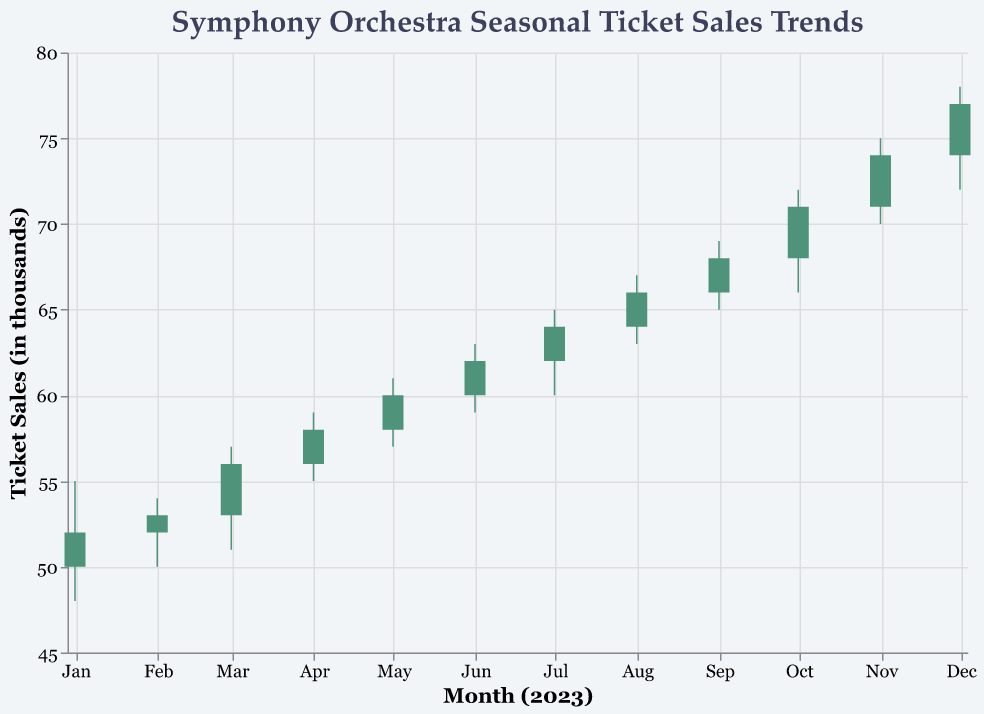What is the title of the figure? The title is located at the top of the figure and reads “Symphony Orchestra Seasonal Ticket Sales Trends”
Answer: Symphony Orchestra Seasonal Ticket Sales Trends What does the color green in the bars signify? According to the color legend, green bars indicate that the 'Close' value is higher than the 'Open' value for that month
Answer: 'Close' > 'Open' In which month did the ticket sales see the highest 'Close' value? The highest 'Close' value is seen in the month of December with a close value of 77 (thousand)
Answer: December What was the 'Volume' of ticket sales in July? The 'Volume' is given in the data and corresponds to a value of 380 (thousand) in July
Answer: 380 (thousand) How does the 'Close' value in September compare to the 'Open' value in the same month? In September, the 'Open' value is 66 (thousand) and the 'Close' value is 68 (thousand), so the 'Close' value is higher than the 'Open' value
Answer: 'Close' > 'Open' What is the difference between the highest and lowest 'High' values observed throughout the year? The highest 'High' value is 78 (thousand) in December and the lowest 'High' value is 54 (thousand) in February, so the difference is 78 - 54 = 24
Answer: 24 What is the average 'Close' value for the first quarter (January to March)? The 'Close' values for January, February, and March are 52, 53, and 56 respectively. The average is (52 + 53 + 56) / 3 = 53.67
Answer: 53.67 Which month shows the greatest 'Low' value, and what is it? The highest 'Low' value is observed in December with a 'Low' value of 72 (thousand)
Answer: December In which months did the 'Open' value exceed the 'Close' value? The figure uses red bars to indicate months where the 'Open' value exceeded the 'Close' value. Observing the colors, none of the months have red bars, implying the 'Open' value never exceeded the 'Close' value
Answer: None 